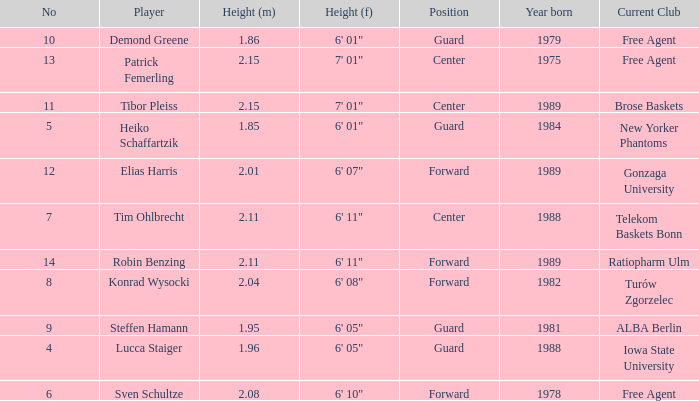Name the height for the player born 1989 and height 2.11 6' 11". 